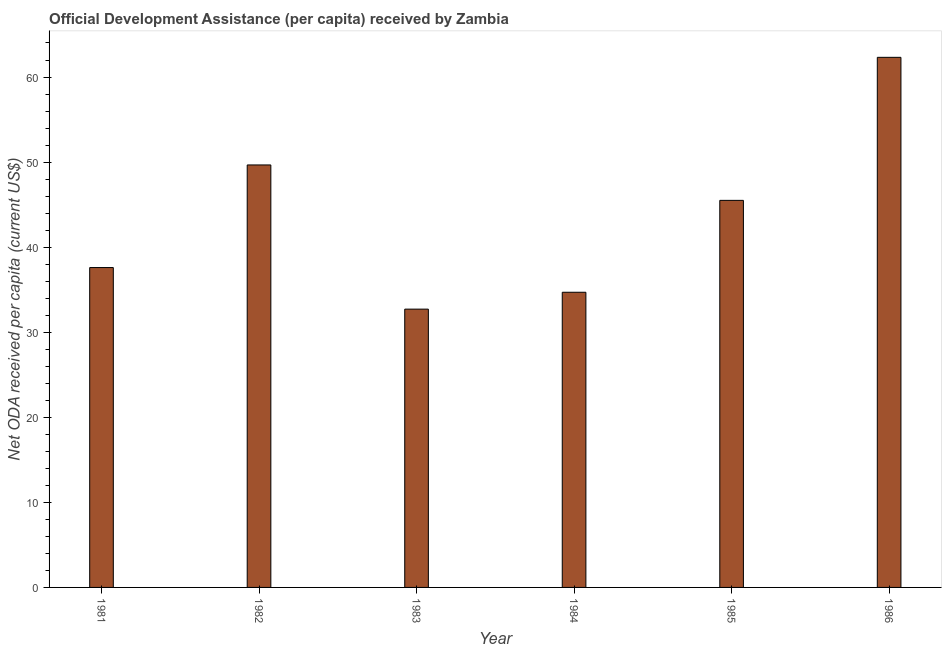What is the title of the graph?
Your answer should be very brief. Official Development Assistance (per capita) received by Zambia. What is the label or title of the X-axis?
Keep it short and to the point. Year. What is the label or title of the Y-axis?
Offer a terse response. Net ODA received per capita (current US$). What is the net oda received per capita in 1981?
Make the answer very short. 37.6. Across all years, what is the maximum net oda received per capita?
Offer a terse response. 62.31. Across all years, what is the minimum net oda received per capita?
Make the answer very short. 32.71. In which year was the net oda received per capita minimum?
Keep it short and to the point. 1983. What is the sum of the net oda received per capita?
Your answer should be compact. 262.49. What is the difference between the net oda received per capita in 1983 and 1985?
Your answer should be compact. -12.79. What is the average net oda received per capita per year?
Give a very brief answer. 43.75. What is the median net oda received per capita?
Give a very brief answer. 41.55. What is the ratio of the net oda received per capita in 1981 to that in 1984?
Your response must be concise. 1.08. Is the net oda received per capita in 1985 less than that in 1986?
Keep it short and to the point. Yes. Is the difference between the net oda received per capita in 1982 and 1984 greater than the difference between any two years?
Offer a terse response. No. What is the difference between the highest and the second highest net oda received per capita?
Make the answer very short. 12.65. What is the difference between the highest and the lowest net oda received per capita?
Ensure brevity in your answer.  29.6. How many years are there in the graph?
Provide a succinct answer. 6. What is the difference between two consecutive major ticks on the Y-axis?
Offer a terse response. 10. What is the Net ODA received per capita (current US$) of 1981?
Keep it short and to the point. 37.6. What is the Net ODA received per capita (current US$) of 1982?
Your answer should be very brief. 49.66. What is the Net ODA received per capita (current US$) in 1983?
Give a very brief answer. 32.71. What is the Net ODA received per capita (current US$) in 1984?
Give a very brief answer. 34.7. What is the Net ODA received per capita (current US$) in 1985?
Offer a terse response. 45.5. What is the Net ODA received per capita (current US$) of 1986?
Make the answer very short. 62.31. What is the difference between the Net ODA received per capita (current US$) in 1981 and 1982?
Offer a terse response. -12.06. What is the difference between the Net ODA received per capita (current US$) in 1981 and 1983?
Your response must be concise. 4.89. What is the difference between the Net ODA received per capita (current US$) in 1981 and 1984?
Your answer should be very brief. 2.9. What is the difference between the Net ODA received per capita (current US$) in 1981 and 1985?
Offer a terse response. -7.9. What is the difference between the Net ODA received per capita (current US$) in 1981 and 1986?
Ensure brevity in your answer.  -24.71. What is the difference between the Net ODA received per capita (current US$) in 1982 and 1983?
Provide a short and direct response. 16.95. What is the difference between the Net ODA received per capita (current US$) in 1982 and 1984?
Offer a very short reply. 14.97. What is the difference between the Net ODA received per capita (current US$) in 1982 and 1985?
Keep it short and to the point. 4.16. What is the difference between the Net ODA received per capita (current US$) in 1982 and 1986?
Provide a short and direct response. -12.65. What is the difference between the Net ODA received per capita (current US$) in 1983 and 1984?
Offer a very short reply. -1.98. What is the difference between the Net ODA received per capita (current US$) in 1983 and 1985?
Make the answer very short. -12.79. What is the difference between the Net ODA received per capita (current US$) in 1983 and 1986?
Your answer should be very brief. -29.6. What is the difference between the Net ODA received per capita (current US$) in 1984 and 1985?
Your response must be concise. -10.8. What is the difference between the Net ODA received per capita (current US$) in 1984 and 1986?
Keep it short and to the point. -27.62. What is the difference between the Net ODA received per capita (current US$) in 1985 and 1986?
Make the answer very short. -16.81. What is the ratio of the Net ODA received per capita (current US$) in 1981 to that in 1982?
Ensure brevity in your answer.  0.76. What is the ratio of the Net ODA received per capita (current US$) in 1981 to that in 1983?
Your answer should be compact. 1.15. What is the ratio of the Net ODA received per capita (current US$) in 1981 to that in 1984?
Ensure brevity in your answer.  1.08. What is the ratio of the Net ODA received per capita (current US$) in 1981 to that in 1985?
Offer a terse response. 0.83. What is the ratio of the Net ODA received per capita (current US$) in 1981 to that in 1986?
Offer a very short reply. 0.6. What is the ratio of the Net ODA received per capita (current US$) in 1982 to that in 1983?
Give a very brief answer. 1.52. What is the ratio of the Net ODA received per capita (current US$) in 1982 to that in 1984?
Keep it short and to the point. 1.43. What is the ratio of the Net ODA received per capita (current US$) in 1982 to that in 1985?
Keep it short and to the point. 1.09. What is the ratio of the Net ODA received per capita (current US$) in 1982 to that in 1986?
Provide a short and direct response. 0.8. What is the ratio of the Net ODA received per capita (current US$) in 1983 to that in 1984?
Offer a terse response. 0.94. What is the ratio of the Net ODA received per capita (current US$) in 1983 to that in 1985?
Provide a short and direct response. 0.72. What is the ratio of the Net ODA received per capita (current US$) in 1983 to that in 1986?
Make the answer very short. 0.53. What is the ratio of the Net ODA received per capita (current US$) in 1984 to that in 1985?
Your answer should be very brief. 0.76. What is the ratio of the Net ODA received per capita (current US$) in 1984 to that in 1986?
Your response must be concise. 0.56. What is the ratio of the Net ODA received per capita (current US$) in 1985 to that in 1986?
Your response must be concise. 0.73. 